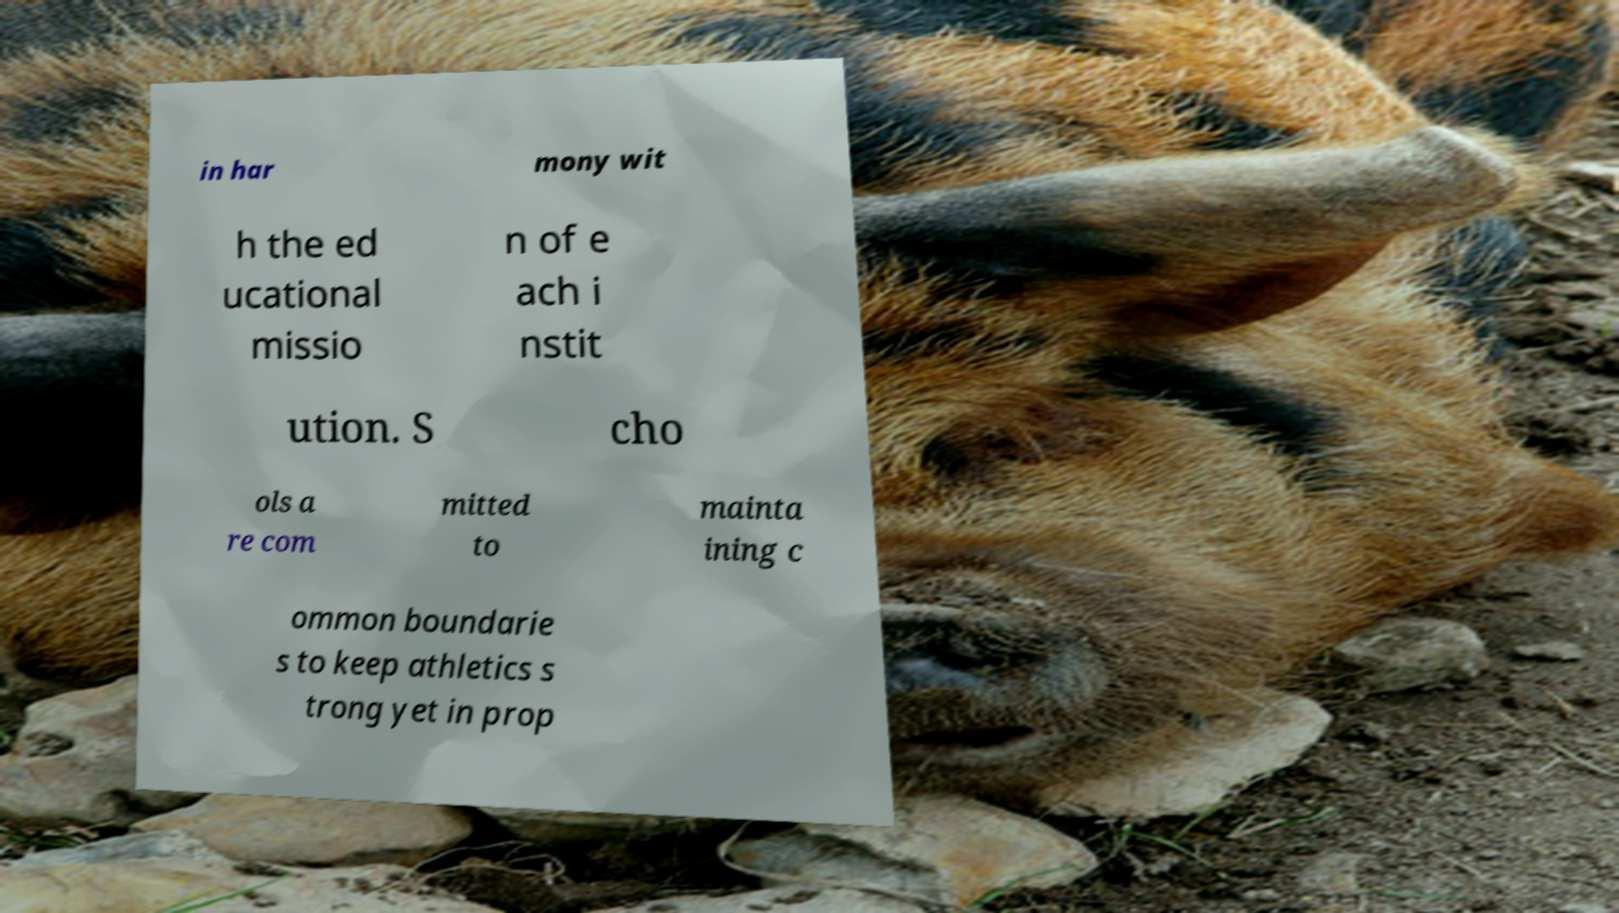Could you extract and type out the text from this image? in har mony wit h the ed ucational missio n of e ach i nstit ution. S cho ols a re com mitted to mainta ining c ommon boundarie s to keep athletics s trong yet in prop 